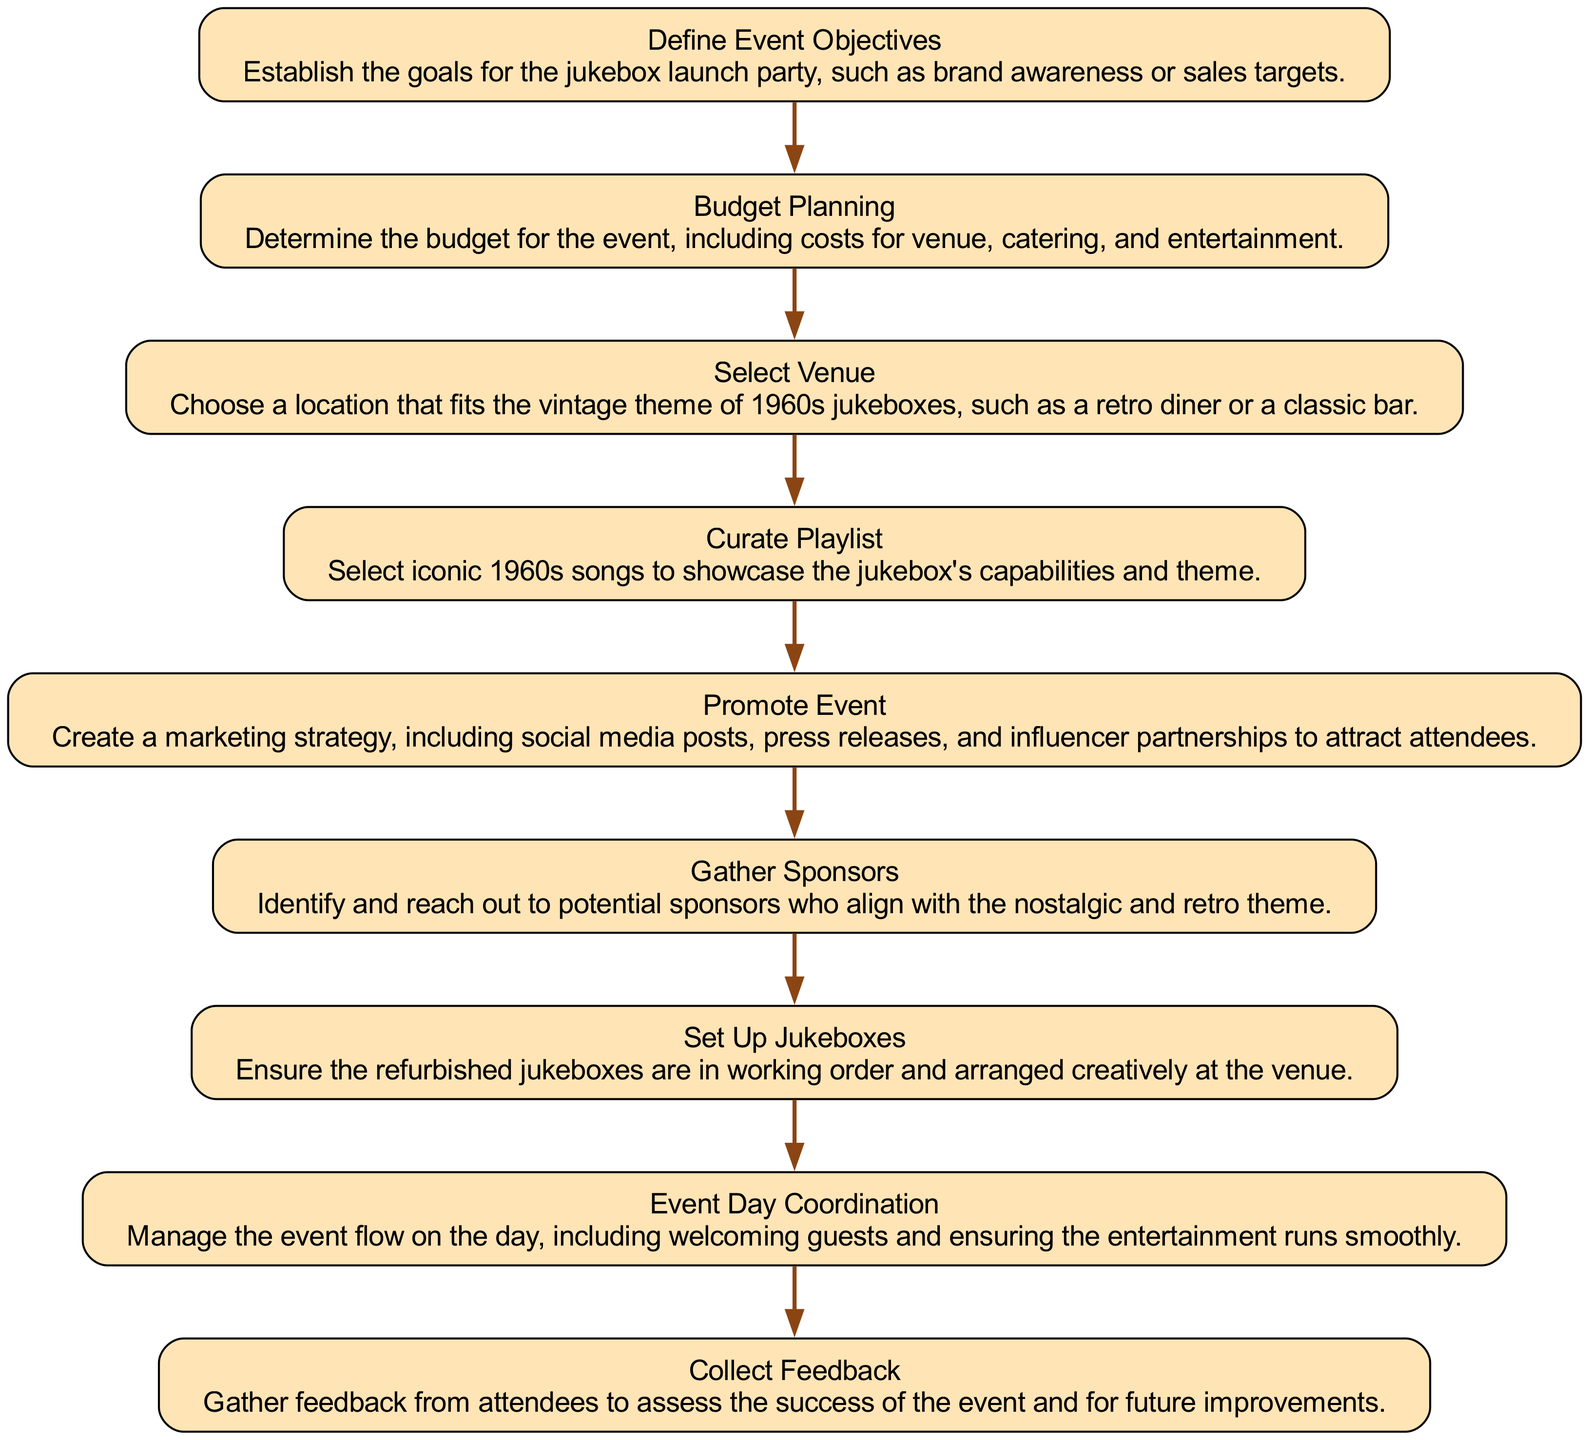What is the first step in the event planning workflow? The diagram shows that the first step is "Define Event Objectives." This can be identified by looking at the initial node in the flow chart.
Answer: Define Event Objectives How many nodes are present in the diagram? Counting the nodes listed in the diagram, there are a total of nine distinct steps.
Answer: 9 What follows after "Budget Planning"? The edge from "Budget Planning" points to "Select Venue," indicating that it is the next step in the sequence.
Answer: Select Venue Which step comes after "Promote Event"? Following "Promote Event," the next node as per the flow is "Gather Sponsors." This indicates the flow of steps in the process.
Answer: Gather Sponsors Is "Set Up Jukeboxes" the last step in the process? By examining the diagram, "Set Up Jukeboxes" is followed by "Event Day Coordination," meaning it is not the final step.
Answer: No What is the main purpose of "Collect Feedback"? The feedback collection is aimed at assessing the success of the event and identifying areas for improvement, serving as an evaluative step in the workflow.
Answer: Assess success How many edges connect the nodes in the flow chart? Each step leads to the next with a directed edge, and since there are nine nodes, there are eight edges connecting them.
Answer: 8 What is the description of "Curate Playlist"? The description of "Curate Playlist" specifies the selection of iconic 1960s songs to showcase the jukebox, which emphasizes the thematic importance of the step.
Answer: Select iconic 1960s songs What type of event venue is suggested in the workflow? The diagram suggests selecting a location that fits the "vintage theme of 1960s jukeboxes," implying a nostalgic atmosphere like a retro diner or bar.
Answer: Vintage theme 